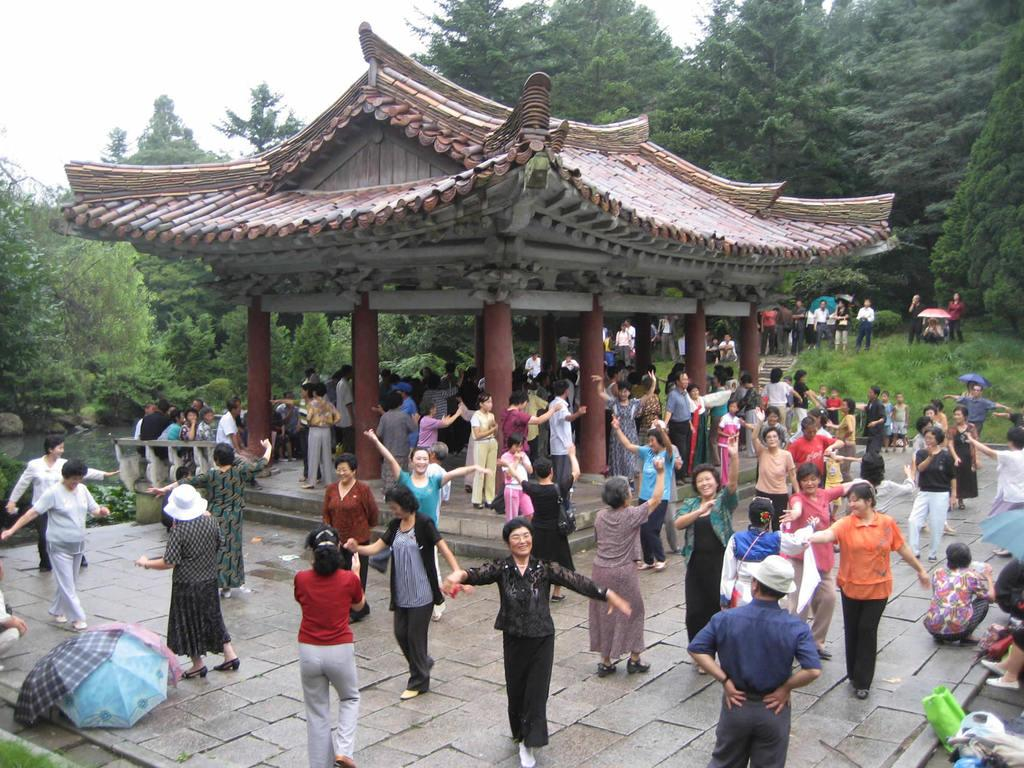Who or what is present in the image? There are people in the image. What type of vegetation can be seen on the right side of the image? There is grass on the right side of the image. What can be seen in the background of the image? There are trees and the sky visible in the background of the image. What type of board game is being played by the people in the image? There is no board game present in the image; it only shows people and the surrounding environment. 